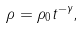Convert formula to latex. <formula><loc_0><loc_0><loc_500><loc_500>\rho = \rho _ { 0 } t ^ { - \gamma } ,</formula> 